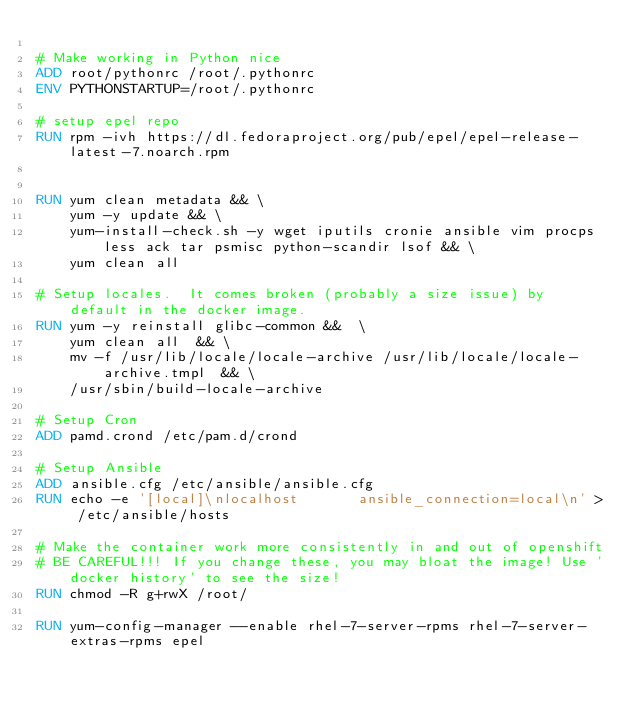Convert code to text. <code><loc_0><loc_0><loc_500><loc_500><_Dockerfile_>
# Make working in Python nice
ADD root/pythonrc /root/.pythonrc
ENV PYTHONSTARTUP=/root/.pythonrc

# setup epel repo
RUN rpm -ivh https://dl.fedoraproject.org/pub/epel/epel-release-latest-7.noarch.rpm


RUN yum clean metadata && \
    yum -y update && \
    yum-install-check.sh -y wget iputils cronie ansible vim procps less ack tar psmisc python-scandir lsof && \
    yum clean all

# Setup locales.  It comes broken (probably a size issue) by default in the docker image.
RUN yum -y reinstall glibc-common &&  \
    yum clean all  && \
    mv -f /usr/lib/locale/locale-archive /usr/lib/locale/locale-archive.tmpl  && \
    /usr/sbin/build-locale-archive

# Setup Cron
ADD pamd.crond /etc/pam.d/crond

# Setup Ansible
ADD ansible.cfg /etc/ansible/ansible.cfg
RUN echo -e '[local]\nlocalhost       ansible_connection=local\n' > /etc/ansible/hosts

# Make the container work more consistently in and out of openshift
# BE CAREFUL!!! If you change these, you may bloat the image! Use 'docker history' to see the size!
RUN chmod -R g+rwX /root/

RUN yum-config-manager --enable rhel-7-server-rpms rhel-7-server-extras-rpms epel
</code> 